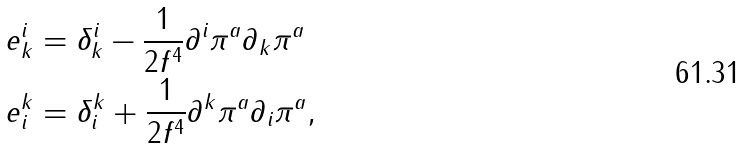<formula> <loc_0><loc_0><loc_500><loc_500>e ^ { i } _ { k } & = \delta ^ { i } _ { k } - \frac { 1 } { 2 f ^ { 4 } } \partial ^ { i } \pi ^ { a } \partial _ { k } \pi ^ { a } \\ e ^ { k } _ { i } & = \delta ^ { k } _ { i } + \frac { 1 } { 2 f ^ { 4 } } \partial ^ { k } \pi ^ { a } \partial _ { i } \pi ^ { a } ,</formula> 